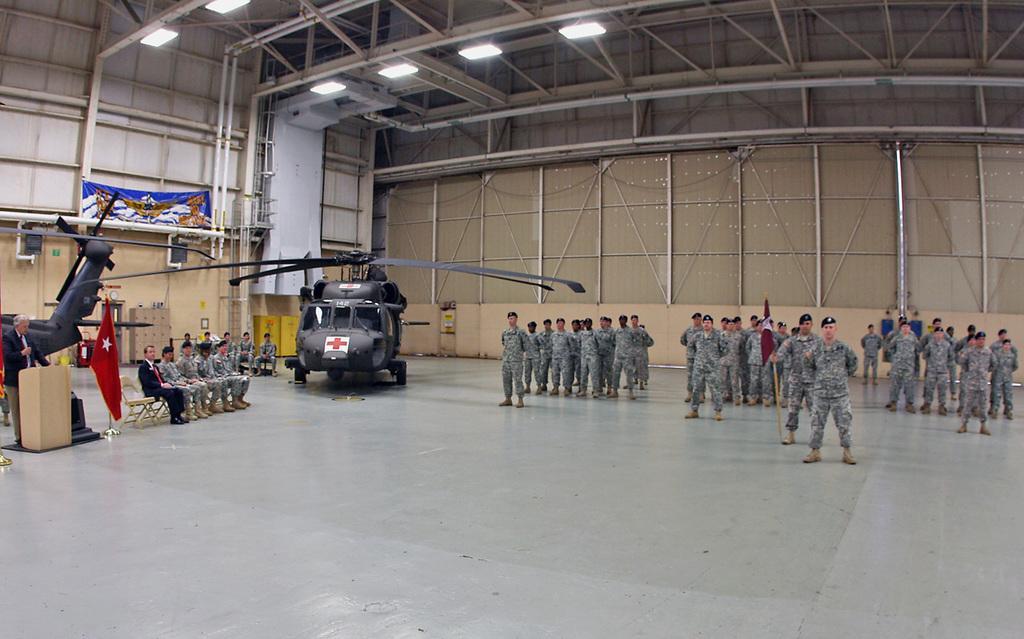Could you give a brief overview of what you see in this image? In this image we can see group of persons standing on the floor. On the left side of the image we can see person sitting on the chairs, helicopters, flag. In the background we can see wall, pillars and lights. 